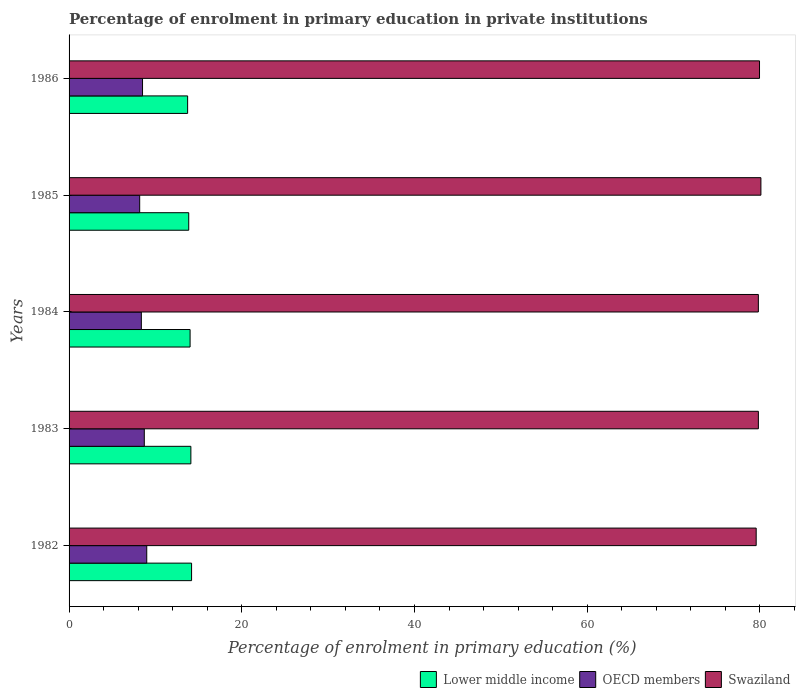How many different coloured bars are there?
Offer a very short reply. 3. Are the number of bars on each tick of the Y-axis equal?
Offer a very short reply. Yes. How many bars are there on the 3rd tick from the top?
Provide a succinct answer. 3. What is the label of the 2nd group of bars from the top?
Provide a short and direct response. 1985. What is the percentage of enrolment in primary education in Swaziland in 1984?
Provide a succinct answer. 79.82. Across all years, what is the maximum percentage of enrolment in primary education in Swaziland?
Your answer should be very brief. 80.11. Across all years, what is the minimum percentage of enrolment in primary education in Swaziland?
Provide a short and direct response. 79.57. In which year was the percentage of enrolment in primary education in Swaziland maximum?
Provide a succinct answer. 1985. In which year was the percentage of enrolment in primary education in Swaziland minimum?
Offer a terse response. 1982. What is the total percentage of enrolment in primary education in Lower middle income in the graph?
Ensure brevity in your answer.  69.89. What is the difference between the percentage of enrolment in primary education in OECD members in 1983 and that in 1985?
Offer a terse response. 0.53. What is the difference between the percentage of enrolment in primary education in Lower middle income in 1983 and the percentage of enrolment in primary education in Swaziland in 1982?
Provide a short and direct response. -65.46. What is the average percentage of enrolment in primary education in OECD members per year?
Provide a short and direct response. 8.55. In the year 1982, what is the difference between the percentage of enrolment in primary education in Lower middle income and percentage of enrolment in primary education in OECD members?
Make the answer very short. 5.19. In how many years, is the percentage of enrolment in primary education in OECD members greater than 44 %?
Your response must be concise. 0. What is the ratio of the percentage of enrolment in primary education in Swaziland in 1982 to that in 1983?
Your answer should be compact. 1. What is the difference between the highest and the second highest percentage of enrolment in primary education in Lower middle income?
Your answer should be compact. 0.08. What is the difference between the highest and the lowest percentage of enrolment in primary education in Lower middle income?
Provide a short and direct response. 0.46. In how many years, is the percentage of enrolment in primary education in Lower middle income greater than the average percentage of enrolment in primary education in Lower middle income taken over all years?
Offer a terse response. 3. Is the sum of the percentage of enrolment in primary education in OECD members in 1984 and 1985 greater than the maximum percentage of enrolment in primary education in Swaziland across all years?
Your answer should be compact. No. What does the 3rd bar from the top in 1983 represents?
Offer a very short reply. Lower middle income. What does the 3rd bar from the bottom in 1984 represents?
Your answer should be very brief. Swaziland. Is it the case that in every year, the sum of the percentage of enrolment in primary education in Swaziland and percentage of enrolment in primary education in OECD members is greater than the percentage of enrolment in primary education in Lower middle income?
Your response must be concise. Yes. How many bars are there?
Provide a short and direct response. 15. Are all the bars in the graph horizontal?
Ensure brevity in your answer.  Yes. What is the difference between two consecutive major ticks on the X-axis?
Ensure brevity in your answer.  20. Are the values on the major ticks of X-axis written in scientific E-notation?
Give a very brief answer. No. Does the graph contain grids?
Your answer should be very brief. No. Where does the legend appear in the graph?
Keep it short and to the point. Bottom right. How many legend labels are there?
Your answer should be compact. 3. How are the legend labels stacked?
Make the answer very short. Horizontal. What is the title of the graph?
Provide a short and direct response. Percentage of enrolment in primary education in private institutions. What is the label or title of the X-axis?
Provide a short and direct response. Percentage of enrolment in primary education (%). What is the Percentage of enrolment in primary education (%) in Lower middle income in 1982?
Your response must be concise. 14.19. What is the Percentage of enrolment in primary education (%) in OECD members in 1982?
Keep it short and to the point. 8.99. What is the Percentage of enrolment in primary education (%) in Swaziland in 1982?
Your answer should be very brief. 79.57. What is the Percentage of enrolment in primary education (%) in Lower middle income in 1983?
Keep it short and to the point. 14.1. What is the Percentage of enrolment in primary education (%) in OECD members in 1983?
Your answer should be compact. 8.71. What is the Percentage of enrolment in primary education (%) of Swaziland in 1983?
Your answer should be compact. 79.82. What is the Percentage of enrolment in primary education (%) in Lower middle income in 1984?
Make the answer very short. 14.01. What is the Percentage of enrolment in primary education (%) of OECD members in 1984?
Give a very brief answer. 8.37. What is the Percentage of enrolment in primary education (%) of Swaziland in 1984?
Provide a short and direct response. 79.82. What is the Percentage of enrolment in primary education (%) in Lower middle income in 1985?
Provide a succinct answer. 13.86. What is the Percentage of enrolment in primary education (%) of OECD members in 1985?
Your response must be concise. 8.18. What is the Percentage of enrolment in primary education (%) of Swaziland in 1985?
Your answer should be very brief. 80.11. What is the Percentage of enrolment in primary education (%) of Lower middle income in 1986?
Offer a terse response. 13.73. What is the Percentage of enrolment in primary education (%) of OECD members in 1986?
Offer a very short reply. 8.51. What is the Percentage of enrolment in primary education (%) of Swaziland in 1986?
Make the answer very short. 79.95. Across all years, what is the maximum Percentage of enrolment in primary education (%) in Lower middle income?
Make the answer very short. 14.19. Across all years, what is the maximum Percentage of enrolment in primary education (%) in OECD members?
Ensure brevity in your answer.  8.99. Across all years, what is the maximum Percentage of enrolment in primary education (%) in Swaziland?
Your response must be concise. 80.11. Across all years, what is the minimum Percentage of enrolment in primary education (%) of Lower middle income?
Your answer should be very brief. 13.73. Across all years, what is the minimum Percentage of enrolment in primary education (%) in OECD members?
Ensure brevity in your answer.  8.18. Across all years, what is the minimum Percentage of enrolment in primary education (%) in Swaziland?
Make the answer very short. 79.57. What is the total Percentage of enrolment in primary education (%) in Lower middle income in the graph?
Your answer should be compact. 69.89. What is the total Percentage of enrolment in primary education (%) of OECD members in the graph?
Your answer should be very brief. 42.76. What is the total Percentage of enrolment in primary education (%) of Swaziland in the graph?
Ensure brevity in your answer.  399.28. What is the difference between the Percentage of enrolment in primary education (%) of Lower middle income in 1982 and that in 1983?
Make the answer very short. 0.08. What is the difference between the Percentage of enrolment in primary education (%) of OECD members in 1982 and that in 1983?
Ensure brevity in your answer.  0.28. What is the difference between the Percentage of enrolment in primary education (%) in Swaziland in 1982 and that in 1983?
Make the answer very short. -0.25. What is the difference between the Percentage of enrolment in primary education (%) in Lower middle income in 1982 and that in 1984?
Keep it short and to the point. 0.17. What is the difference between the Percentage of enrolment in primary education (%) of OECD members in 1982 and that in 1984?
Provide a succinct answer. 0.63. What is the difference between the Percentage of enrolment in primary education (%) of Swaziland in 1982 and that in 1984?
Make the answer very short. -0.25. What is the difference between the Percentage of enrolment in primary education (%) in Lower middle income in 1982 and that in 1985?
Make the answer very short. 0.33. What is the difference between the Percentage of enrolment in primary education (%) in OECD members in 1982 and that in 1985?
Keep it short and to the point. 0.82. What is the difference between the Percentage of enrolment in primary education (%) of Swaziland in 1982 and that in 1985?
Provide a short and direct response. -0.55. What is the difference between the Percentage of enrolment in primary education (%) of Lower middle income in 1982 and that in 1986?
Offer a terse response. 0.46. What is the difference between the Percentage of enrolment in primary education (%) in OECD members in 1982 and that in 1986?
Make the answer very short. 0.49. What is the difference between the Percentage of enrolment in primary education (%) in Swaziland in 1982 and that in 1986?
Your answer should be very brief. -0.39. What is the difference between the Percentage of enrolment in primary education (%) of Lower middle income in 1983 and that in 1984?
Give a very brief answer. 0.09. What is the difference between the Percentage of enrolment in primary education (%) of OECD members in 1983 and that in 1984?
Keep it short and to the point. 0.34. What is the difference between the Percentage of enrolment in primary education (%) in Swaziland in 1983 and that in 1984?
Ensure brevity in your answer.  0. What is the difference between the Percentage of enrolment in primary education (%) in Lower middle income in 1983 and that in 1985?
Make the answer very short. 0.25. What is the difference between the Percentage of enrolment in primary education (%) of OECD members in 1983 and that in 1985?
Give a very brief answer. 0.53. What is the difference between the Percentage of enrolment in primary education (%) in Swaziland in 1983 and that in 1985?
Ensure brevity in your answer.  -0.29. What is the difference between the Percentage of enrolment in primary education (%) in Lower middle income in 1983 and that in 1986?
Your answer should be very brief. 0.38. What is the difference between the Percentage of enrolment in primary education (%) in OECD members in 1983 and that in 1986?
Keep it short and to the point. 0.2. What is the difference between the Percentage of enrolment in primary education (%) in Swaziland in 1983 and that in 1986?
Your response must be concise. -0.13. What is the difference between the Percentage of enrolment in primary education (%) of Lower middle income in 1984 and that in 1985?
Make the answer very short. 0.16. What is the difference between the Percentage of enrolment in primary education (%) of OECD members in 1984 and that in 1985?
Give a very brief answer. 0.19. What is the difference between the Percentage of enrolment in primary education (%) of Swaziland in 1984 and that in 1985?
Ensure brevity in your answer.  -0.29. What is the difference between the Percentage of enrolment in primary education (%) of Lower middle income in 1984 and that in 1986?
Give a very brief answer. 0.29. What is the difference between the Percentage of enrolment in primary education (%) of OECD members in 1984 and that in 1986?
Offer a terse response. -0.14. What is the difference between the Percentage of enrolment in primary education (%) in Swaziland in 1984 and that in 1986?
Provide a succinct answer. -0.13. What is the difference between the Percentage of enrolment in primary education (%) of Lower middle income in 1985 and that in 1986?
Offer a very short reply. 0.13. What is the difference between the Percentage of enrolment in primary education (%) in OECD members in 1985 and that in 1986?
Offer a terse response. -0.33. What is the difference between the Percentage of enrolment in primary education (%) of Swaziland in 1985 and that in 1986?
Give a very brief answer. 0.16. What is the difference between the Percentage of enrolment in primary education (%) of Lower middle income in 1982 and the Percentage of enrolment in primary education (%) of OECD members in 1983?
Your answer should be compact. 5.47. What is the difference between the Percentage of enrolment in primary education (%) of Lower middle income in 1982 and the Percentage of enrolment in primary education (%) of Swaziland in 1983?
Ensure brevity in your answer.  -65.63. What is the difference between the Percentage of enrolment in primary education (%) of OECD members in 1982 and the Percentage of enrolment in primary education (%) of Swaziland in 1983?
Your answer should be compact. -70.83. What is the difference between the Percentage of enrolment in primary education (%) in Lower middle income in 1982 and the Percentage of enrolment in primary education (%) in OECD members in 1984?
Your answer should be compact. 5.82. What is the difference between the Percentage of enrolment in primary education (%) in Lower middle income in 1982 and the Percentage of enrolment in primary education (%) in Swaziland in 1984?
Provide a succinct answer. -65.63. What is the difference between the Percentage of enrolment in primary education (%) in OECD members in 1982 and the Percentage of enrolment in primary education (%) in Swaziland in 1984?
Offer a terse response. -70.83. What is the difference between the Percentage of enrolment in primary education (%) of Lower middle income in 1982 and the Percentage of enrolment in primary education (%) of OECD members in 1985?
Make the answer very short. 6.01. What is the difference between the Percentage of enrolment in primary education (%) of Lower middle income in 1982 and the Percentage of enrolment in primary education (%) of Swaziland in 1985?
Provide a succinct answer. -65.93. What is the difference between the Percentage of enrolment in primary education (%) of OECD members in 1982 and the Percentage of enrolment in primary education (%) of Swaziland in 1985?
Keep it short and to the point. -71.12. What is the difference between the Percentage of enrolment in primary education (%) of Lower middle income in 1982 and the Percentage of enrolment in primary education (%) of OECD members in 1986?
Your response must be concise. 5.68. What is the difference between the Percentage of enrolment in primary education (%) of Lower middle income in 1982 and the Percentage of enrolment in primary education (%) of Swaziland in 1986?
Offer a very short reply. -65.77. What is the difference between the Percentage of enrolment in primary education (%) of OECD members in 1982 and the Percentage of enrolment in primary education (%) of Swaziland in 1986?
Give a very brief answer. -70.96. What is the difference between the Percentage of enrolment in primary education (%) of Lower middle income in 1983 and the Percentage of enrolment in primary education (%) of OECD members in 1984?
Keep it short and to the point. 5.74. What is the difference between the Percentage of enrolment in primary education (%) of Lower middle income in 1983 and the Percentage of enrolment in primary education (%) of Swaziland in 1984?
Your response must be concise. -65.72. What is the difference between the Percentage of enrolment in primary education (%) of OECD members in 1983 and the Percentage of enrolment in primary education (%) of Swaziland in 1984?
Offer a terse response. -71.11. What is the difference between the Percentage of enrolment in primary education (%) in Lower middle income in 1983 and the Percentage of enrolment in primary education (%) in OECD members in 1985?
Your answer should be very brief. 5.93. What is the difference between the Percentage of enrolment in primary education (%) in Lower middle income in 1983 and the Percentage of enrolment in primary education (%) in Swaziland in 1985?
Your response must be concise. -66.01. What is the difference between the Percentage of enrolment in primary education (%) of OECD members in 1983 and the Percentage of enrolment in primary education (%) of Swaziland in 1985?
Your answer should be very brief. -71.4. What is the difference between the Percentage of enrolment in primary education (%) in Lower middle income in 1983 and the Percentage of enrolment in primary education (%) in OECD members in 1986?
Make the answer very short. 5.6. What is the difference between the Percentage of enrolment in primary education (%) in Lower middle income in 1983 and the Percentage of enrolment in primary education (%) in Swaziland in 1986?
Your answer should be very brief. -65.85. What is the difference between the Percentage of enrolment in primary education (%) in OECD members in 1983 and the Percentage of enrolment in primary education (%) in Swaziland in 1986?
Your response must be concise. -71.24. What is the difference between the Percentage of enrolment in primary education (%) in Lower middle income in 1984 and the Percentage of enrolment in primary education (%) in OECD members in 1985?
Provide a succinct answer. 5.84. What is the difference between the Percentage of enrolment in primary education (%) in Lower middle income in 1984 and the Percentage of enrolment in primary education (%) in Swaziland in 1985?
Offer a terse response. -66.1. What is the difference between the Percentage of enrolment in primary education (%) of OECD members in 1984 and the Percentage of enrolment in primary education (%) of Swaziland in 1985?
Your answer should be very brief. -71.75. What is the difference between the Percentage of enrolment in primary education (%) in Lower middle income in 1984 and the Percentage of enrolment in primary education (%) in OECD members in 1986?
Offer a very short reply. 5.51. What is the difference between the Percentage of enrolment in primary education (%) in Lower middle income in 1984 and the Percentage of enrolment in primary education (%) in Swaziland in 1986?
Give a very brief answer. -65.94. What is the difference between the Percentage of enrolment in primary education (%) of OECD members in 1984 and the Percentage of enrolment in primary education (%) of Swaziland in 1986?
Ensure brevity in your answer.  -71.58. What is the difference between the Percentage of enrolment in primary education (%) of Lower middle income in 1985 and the Percentage of enrolment in primary education (%) of OECD members in 1986?
Keep it short and to the point. 5.35. What is the difference between the Percentage of enrolment in primary education (%) of Lower middle income in 1985 and the Percentage of enrolment in primary education (%) of Swaziland in 1986?
Your response must be concise. -66.1. What is the difference between the Percentage of enrolment in primary education (%) of OECD members in 1985 and the Percentage of enrolment in primary education (%) of Swaziland in 1986?
Provide a succinct answer. -71.78. What is the average Percentage of enrolment in primary education (%) in Lower middle income per year?
Offer a terse response. 13.98. What is the average Percentage of enrolment in primary education (%) in OECD members per year?
Offer a terse response. 8.55. What is the average Percentage of enrolment in primary education (%) in Swaziland per year?
Provide a succinct answer. 79.86. In the year 1982, what is the difference between the Percentage of enrolment in primary education (%) of Lower middle income and Percentage of enrolment in primary education (%) of OECD members?
Offer a very short reply. 5.19. In the year 1982, what is the difference between the Percentage of enrolment in primary education (%) in Lower middle income and Percentage of enrolment in primary education (%) in Swaziland?
Keep it short and to the point. -65.38. In the year 1982, what is the difference between the Percentage of enrolment in primary education (%) in OECD members and Percentage of enrolment in primary education (%) in Swaziland?
Keep it short and to the point. -70.57. In the year 1983, what is the difference between the Percentage of enrolment in primary education (%) of Lower middle income and Percentage of enrolment in primary education (%) of OECD members?
Give a very brief answer. 5.39. In the year 1983, what is the difference between the Percentage of enrolment in primary education (%) of Lower middle income and Percentage of enrolment in primary education (%) of Swaziland?
Provide a succinct answer. -65.72. In the year 1983, what is the difference between the Percentage of enrolment in primary education (%) of OECD members and Percentage of enrolment in primary education (%) of Swaziland?
Offer a terse response. -71.11. In the year 1984, what is the difference between the Percentage of enrolment in primary education (%) in Lower middle income and Percentage of enrolment in primary education (%) in OECD members?
Your response must be concise. 5.65. In the year 1984, what is the difference between the Percentage of enrolment in primary education (%) of Lower middle income and Percentage of enrolment in primary education (%) of Swaziland?
Ensure brevity in your answer.  -65.81. In the year 1984, what is the difference between the Percentage of enrolment in primary education (%) in OECD members and Percentage of enrolment in primary education (%) in Swaziland?
Provide a succinct answer. -71.45. In the year 1985, what is the difference between the Percentage of enrolment in primary education (%) in Lower middle income and Percentage of enrolment in primary education (%) in OECD members?
Your answer should be very brief. 5.68. In the year 1985, what is the difference between the Percentage of enrolment in primary education (%) of Lower middle income and Percentage of enrolment in primary education (%) of Swaziland?
Give a very brief answer. -66.26. In the year 1985, what is the difference between the Percentage of enrolment in primary education (%) of OECD members and Percentage of enrolment in primary education (%) of Swaziland?
Keep it short and to the point. -71.94. In the year 1986, what is the difference between the Percentage of enrolment in primary education (%) of Lower middle income and Percentage of enrolment in primary education (%) of OECD members?
Your answer should be compact. 5.22. In the year 1986, what is the difference between the Percentage of enrolment in primary education (%) in Lower middle income and Percentage of enrolment in primary education (%) in Swaziland?
Make the answer very short. -66.22. In the year 1986, what is the difference between the Percentage of enrolment in primary education (%) in OECD members and Percentage of enrolment in primary education (%) in Swaziland?
Give a very brief answer. -71.45. What is the ratio of the Percentage of enrolment in primary education (%) in OECD members in 1982 to that in 1983?
Offer a terse response. 1.03. What is the ratio of the Percentage of enrolment in primary education (%) in Lower middle income in 1982 to that in 1984?
Ensure brevity in your answer.  1.01. What is the ratio of the Percentage of enrolment in primary education (%) in OECD members in 1982 to that in 1984?
Offer a very short reply. 1.07. What is the ratio of the Percentage of enrolment in primary education (%) of Swaziland in 1982 to that in 1984?
Give a very brief answer. 1. What is the ratio of the Percentage of enrolment in primary education (%) in Lower middle income in 1982 to that in 1985?
Provide a succinct answer. 1.02. What is the ratio of the Percentage of enrolment in primary education (%) of OECD members in 1982 to that in 1985?
Offer a terse response. 1.1. What is the ratio of the Percentage of enrolment in primary education (%) in Lower middle income in 1982 to that in 1986?
Your response must be concise. 1.03. What is the ratio of the Percentage of enrolment in primary education (%) of OECD members in 1982 to that in 1986?
Keep it short and to the point. 1.06. What is the ratio of the Percentage of enrolment in primary education (%) of Swaziland in 1982 to that in 1986?
Give a very brief answer. 1. What is the ratio of the Percentage of enrolment in primary education (%) in Lower middle income in 1983 to that in 1984?
Provide a short and direct response. 1.01. What is the ratio of the Percentage of enrolment in primary education (%) in OECD members in 1983 to that in 1984?
Make the answer very short. 1.04. What is the ratio of the Percentage of enrolment in primary education (%) in Swaziland in 1983 to that in 1984?
Provide a succinct answer. 1. What is the ratio of the Percentage of enrolment in primary education (%) in Lower middle income in 1983 to that in 1985?
Keep it short and to the point. 1.02. What is the ratio of the Percentage of enrolment in primary education (%) of OECD members in 1983 to that in 1985?
Your answer should be compact. 1.07. What is the ratio of the Percentage of enrolment in primary education (%) of Swaziland in 1983 to that in 1985?
Your answer should be very brief. 1. What is the ratio of the Percentage of enrolment in primary education (%) in Lower middle income in 1983 to that in 1986?
Offer a terse response. 1.03. What is the ratio of the Percentage of enrolment in primary education (%) in OECD members in 1983 to that in 1986?
Give a very brief answer. 1.02. What is the ratio of the Percentage of enrolment in primary education (%) in Lower middle income in 1984 to that in 1985?
Your answer should be compact. 1.01. What is the ratio of the Percentage of enrolment in primary education (%) of OECD members in 1984 to that in 1985?
Ensure brevity in your answer.  1.02. What is the ratio of the Percentage of enrolment in primary education (%) in Swaziland in 1984 to that in 1985?
Provide a short and direct response. 1. What is the ratio of the Percentage of enrolment in primary education (%) of Lower middle income in 1984 to that in 1986?
Provide a succinct answer. 1.02. What is the ratio of the Percentage of enrolment in primary education (%) of OECD members in 1984 to that in 1986?
Your answer should be compact. 0.98. What is the ratio of the Percentage of enrolment in primary education (%) of Swaziland in 1984 to that in 1986?
Offer a terse response. 1. What is the ratio of the Percentage of enrolment in primary education (%) in Lower middle income in 1985 to that in 1986?
Your answer should be compact. 1.01. What is the ratio of the Percentage of enrolment in primary education (%) of OECD members in 1985 to that in 1986?
Your response must be concise. 0.96. What is the difference between the highest and the second highest Percentage of enrolment in primary education (%) of Lower middle income?
Give a very brief answer. 0.08. What is the difference between the highest and the second highest Percentage of enrolment in primary education (%) of OECD members?
Your response must be concise. 0.28. What is the difference between the highest and the second highest Percentage of enrolment in primary education (%) of Swaziland?
Your response must be concise. 0.16. What is the difference between the highest and the lowest Percentage of enrolment in primary education (%) in Lower middle income?
Provide a succinct answer. 0.46. What is the difference between the highest and the lowest Percentage of enrolment in primary education (%) in OECD members?
Your answer should be very brief. 0.82. What is the difference between the highest and the lowest Percentage of enrolment in primary education (%) in Swaziland?
Make the answer very short. 0.55. 